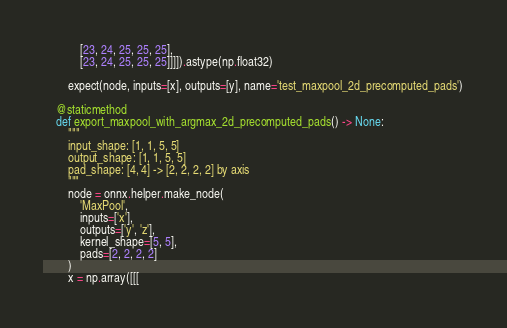<code> <loc_0><loc_0><loc_500><loc_500><_Python_>            [23, 24, 25, 25, 25],
            [23, 24, 25, 25, 25]]]]).astype(np.float32)

        expect(node, inputs=[x], outputs=[y], name='test_maxpool_2d_precomputed_pads')

    @staticmethod
    def export_maxpool_with_argmax_2d_precomputed_pads() -> None:
        """
        input_shape: [1, 1, 5, 5]
        output_shape: [1, 1, 5, 5]
        pad_shape: [4, 4] -> [2, 2, 2, 2] by axis
        """
        node = onnx.helper.make_node(
            'MaxPool',
            inputs=['x'],
            outputs=['y', 'z'],
            kernel_shape=[5, 5],
            pads=[2, 2, 2, 2]
        )
        x = np.array([[[</code> 